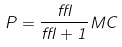<formula> <loc_0><loc_0><loc_500><loc_500>P = \frac { \epsilon } { \epsilon + 1 } M C</formula> 